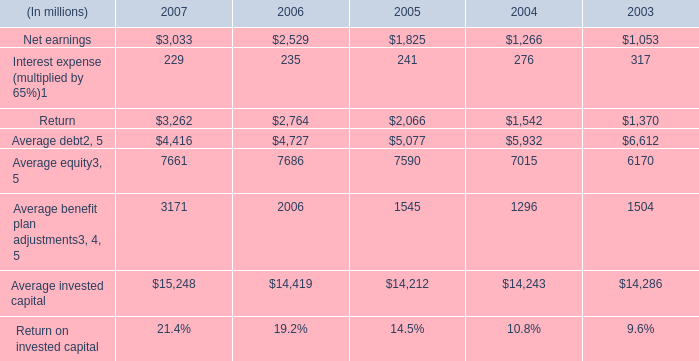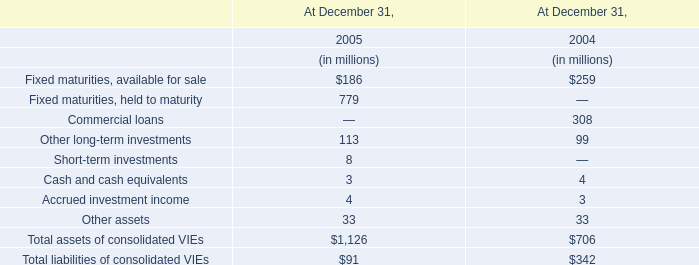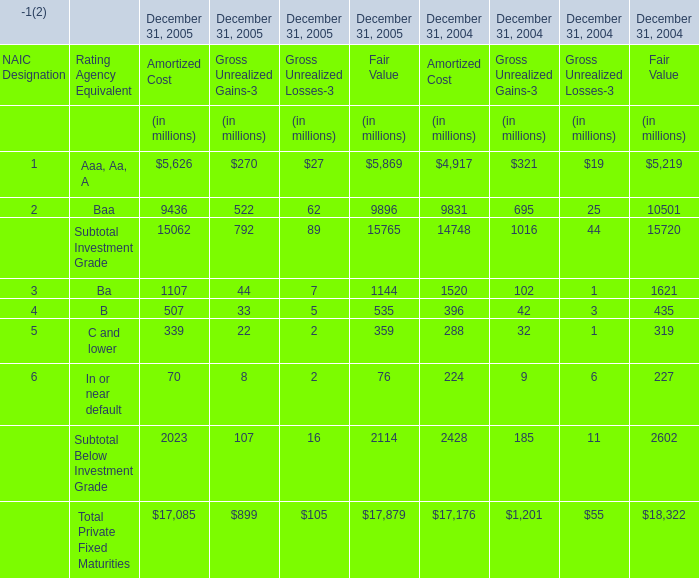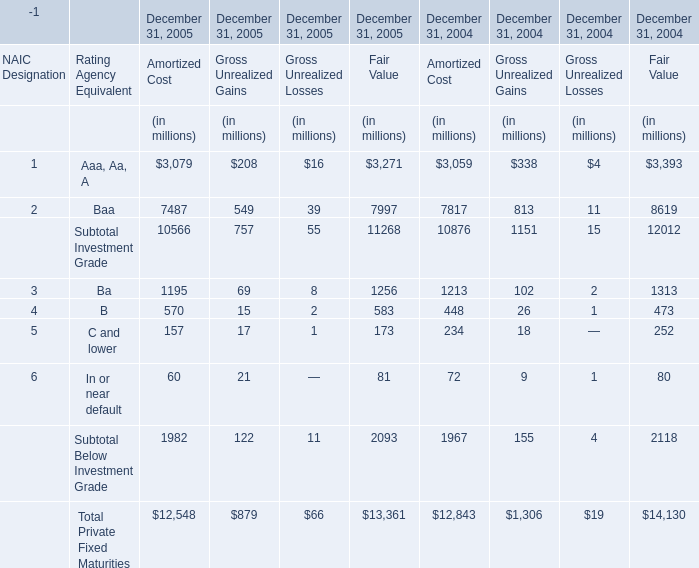What is the ratio of Baa for Gross Unrealized Gains to the total in 2005? 
Computations: (549 / 879)
Answer: 0.62457. 